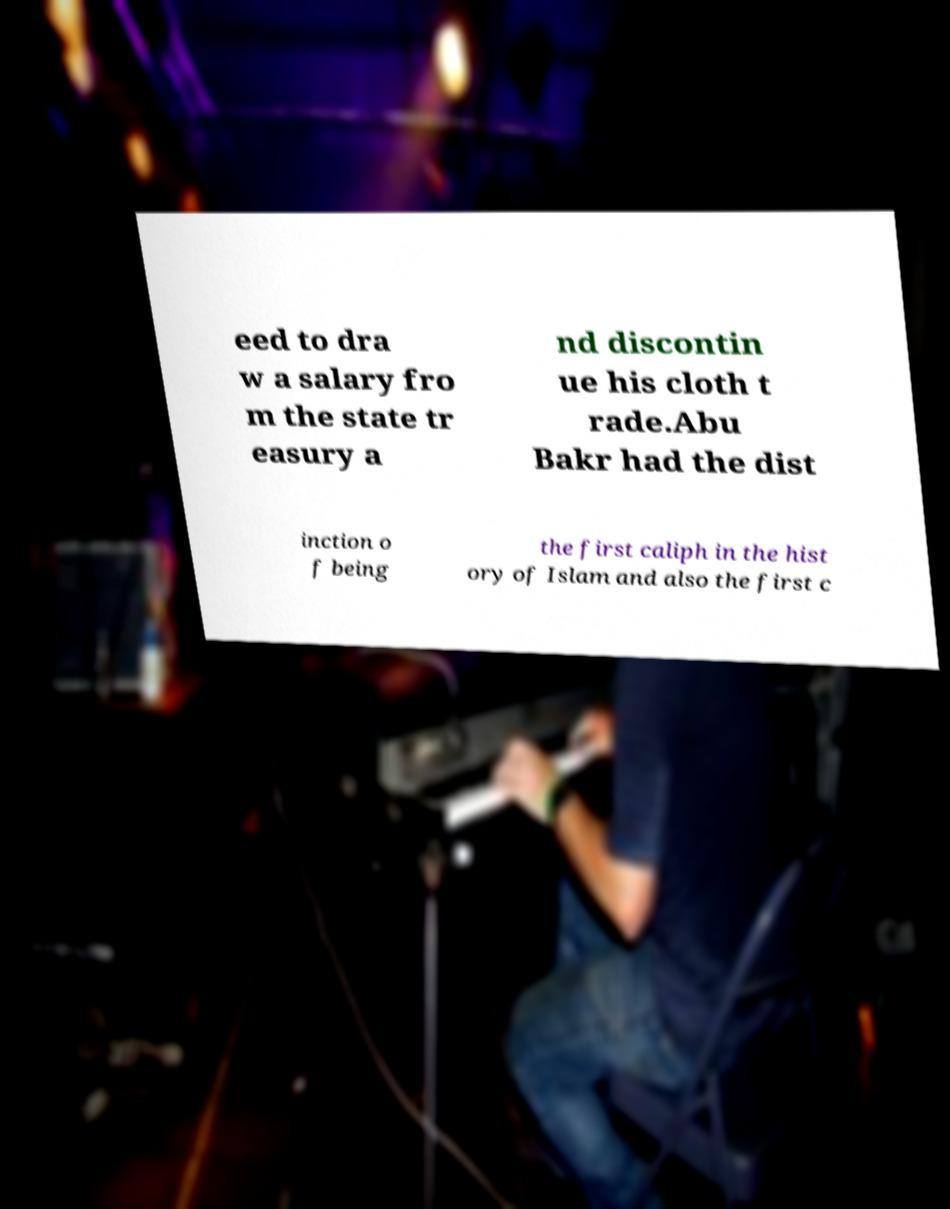Can you read and provide the text displayed in the image?This photo seems to have some interesting text. Can you extract and type it out for me? eed to dra w a salary fro m the state tr easury a nd discontin ue his cloth t rade.Abu Bakr had the dist inction o f being the first caliph in the hist ory of Islam and also the first c 